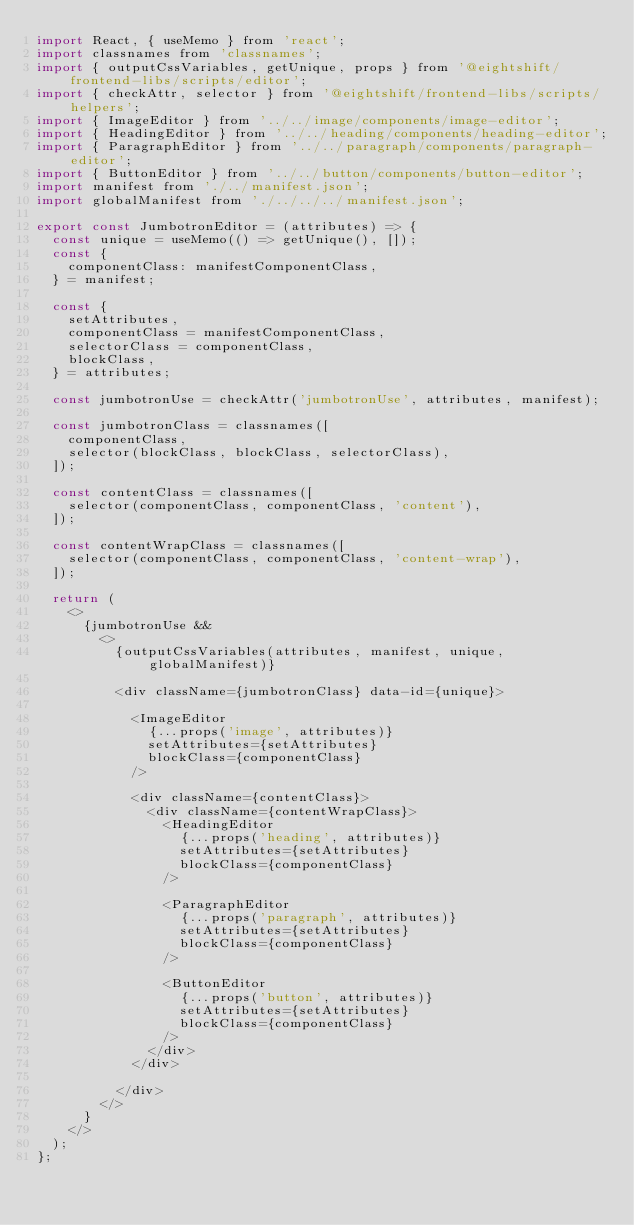Convert code to text. <code><loc_0><loc_0><loc_500><loc_500><_JavaScript_>import React, { useMemo } from 'react';
import classnames from 'classnames';
import { outputCssVariables, getUnique, props } from '@eightshift/frontend-libs/scripts/editor';
import { checkAttr, selector } from '@eightshift/frontend-libs/scripts/helpers';
import { ImageEditor } from '../../image/components/image-editor';
import { HeadingEditor } from '../../heading/components/heading-editor';
import { ParagraphEditor } from '../../paragraph/components/paragraph-editor';
import { ButtonEditor } from '../../button/components/button-editor';
import manifest from './../manifest.json';
import globalManifest from './../../../manifest.json';

export const JumbotronEditor = (attributes) => {
	const unique = useMemo(() => getUnique(), []);
	const {
		componentClass: manifestComponentClass,
	} = manifest;

	const {
		setAttributes,
		componentClass = manifestComponentClass,
		selectorClass = componentClass,
		blockClass,
	} = attributes;

	const jumbotronUse = checkAttr('jumbotronUse', attributes, manifest);

	const jumbotronClass = classnames([
		componentClass,
		selector(blockClass, blockClass, selectorClass),
	]);

	const contentClass = classnames([
		selector(componentClass, componentClass, 'content'),
	]);

	const contentWrapClass = classnames([
		selector(componentClass, componentClass, 'content-wrap'),
	]);

	return (
		<>
			{jumbotronUse &&
				<>
					{outputCssVariables(attributes, manifest, unique, globalManifest)}

					<div className={jumbotronClass} data-id={unique}>

						<ImageEditor
							{...props('image', attributes)}
							setAttributes={setAttributes}
							blockClass={componentClass}
						/>

						<div className={contentClass}>
							<div className={contentWrapClass}>
								<HeadingEditor
									{...props('heading', attributes)}
									setAttributes={setAttributes}
									blockClass={componentClass}
								/>

								<ParagraphEditor
									{...props('paragraph', attributes)}
									setAttributes={setAttributes}
									blockClass={componentClass}
								/>

								<ButtonEditor
									{...props('button', attributes)}
									setAttributes={setAttributes}
									blockClass={componentClass}
								/>
							</div>
						</div>

					</div>
				</>
			}
		</>
	);
};
</code> 